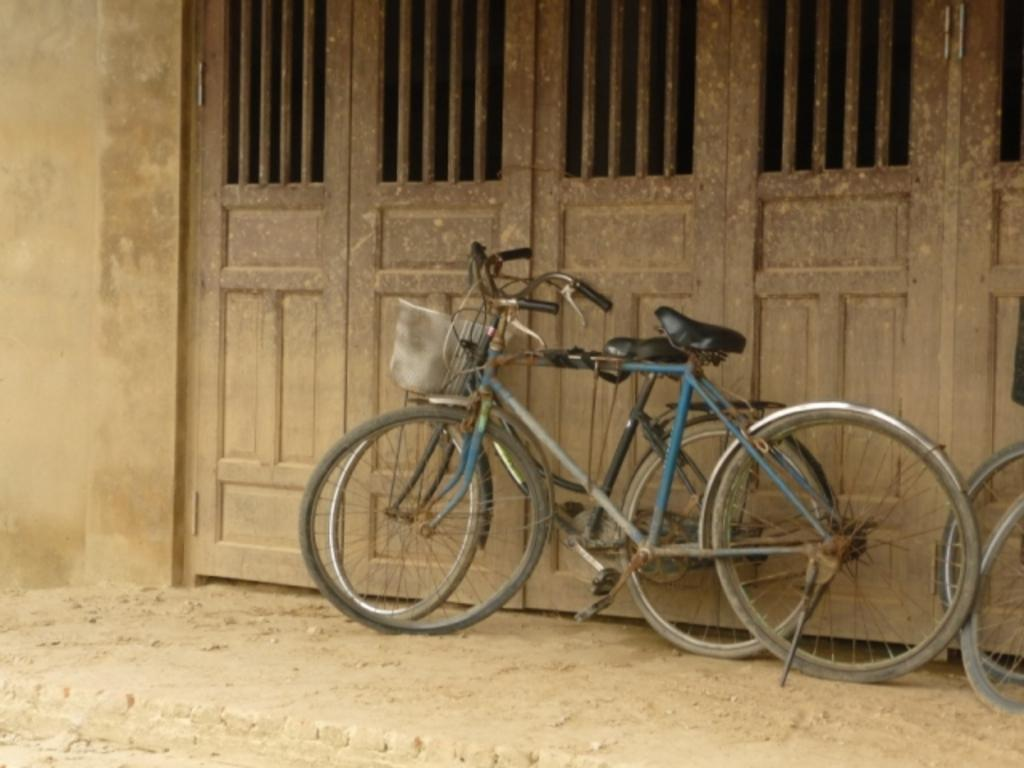What is the main subject of the image? The main subject of the image is bicycles, which are located in the center of the image. What can be seen in the background of the image? There is a door and a wall in the background of the image. What type of fruit is hanging from the bicycles in the image? There is no fruit present in the image, and therefore no such activity can be observed. 